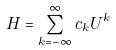Convert formula to latex. <formula><loc_0><loc_0><loc_500><loc_500>H = \sum _ { k = - \infty } ^ { \infty } c _ { k } U ^ { k }</formula> 